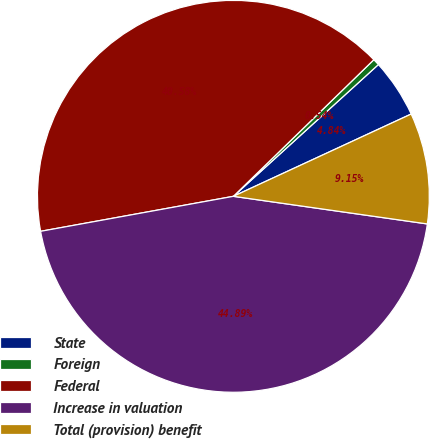Convert chart. <chart><loc_0><loc_0><loc_500><loc_500><pie_chart><fcel>State<fcel>Foreign<fcel>Federal<fcel>Increase in valuation<fcel>Total (provision) benefit<nl><fcel>4.84%<fcel>0.54%<fcel>40.58%<fcel>44.89%<fcel>9.15%<nl></chart> 